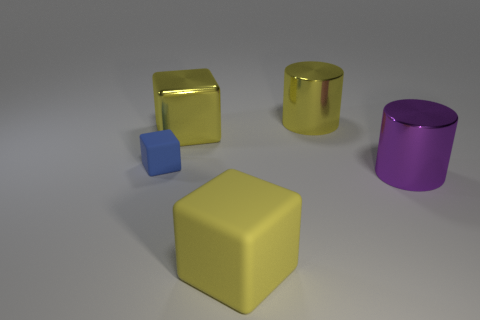Subtract all blue cylinders. Subtract all blue cubes. How many cylinders are left? 2 Add 3 blue rubber things. How many objects exist? 8 Subtract all cylinders. How many objects are left? 3 Subtract all large cylinders. Subtract all purple objects. How many objects are left? 2 Add 3 large yellow shiny things. How many large yellow shiny things are left? 5 Add 4 large red balls. How many large red balls exist? 4 Subtract 0 gray spheres. How many objects are left? 5 